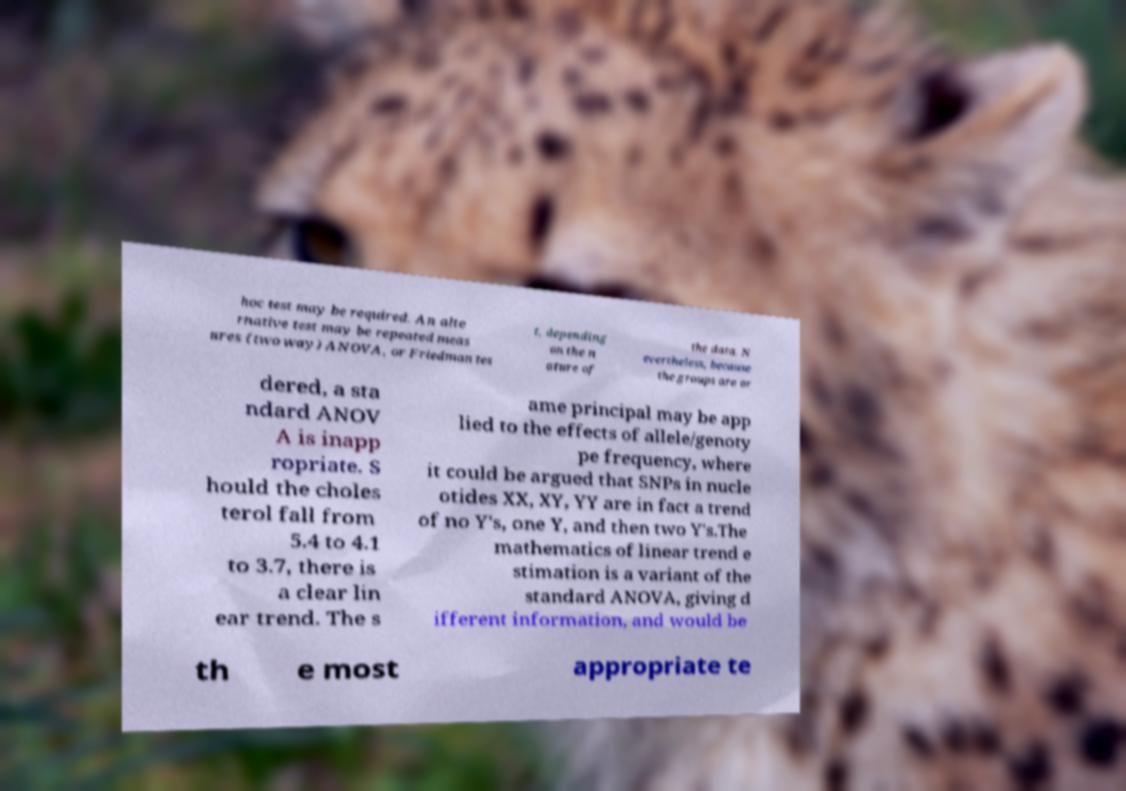For documentation purposes, I need the text within this image transcribed. Could you provide that? hoc test may be required. An alte rnative test may be repeated meas ures (two way) ANOVA, or Friedman tes t, depending on the n ature of the data. N evertheless, because the groups are or dered, a sta ndard ANOV A is inapp ropriate. S hould the choles terol fall from 5.4 to 4.1 to 3.7, there is a clear lin ear trend. The s ame principal may be app lied to the effects of allele/genoty pe frequency, where it could be argued that SNPs in nucle otides XX, XY, YY are in fact a trend of no Y's, one Y, and then two Y's.The mathematics of linear trend e stimation is a variant of the standard ANOVA, giving d ifferent information, and would be th e most appropriate te 